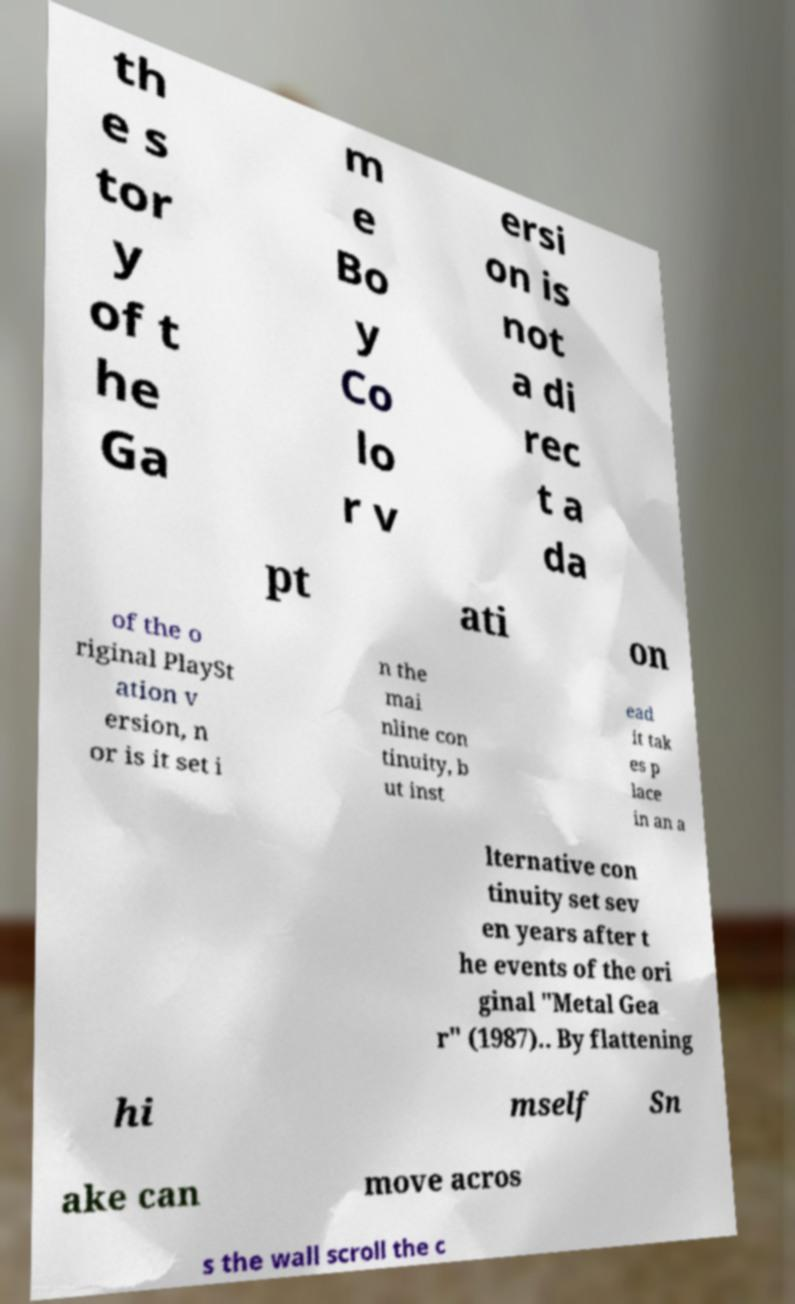Can you accurately transcribe the text from the provided image for me? th e s tor y of t he Ga m e Bo y Co lo r v ersi on is not a di rec t a da pt ati on of the o riginal PlaySt ation v ersion, n or is it set i n the mai nline con tinuity, b ut inst ead it tak es p lace in an a lternative con tinuity set sev en years after t he events of the ori ginal "Metal Gea r" (1987).. By flattening hi mself Sn ake can move acros s the wall scroll the c 